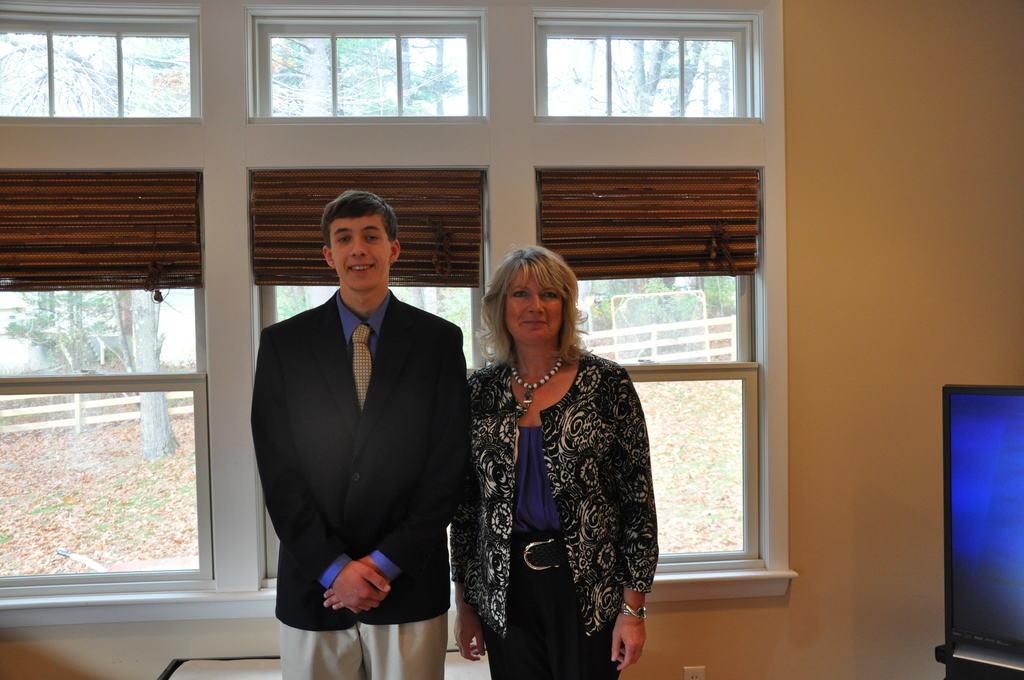Please provide a concise description of this image. There are two people those who are standing in the center of the image, it seems to be there is a screen on the right side of the image and there are glass windows behind them and there are boundaries and trees in the outside the windows. 